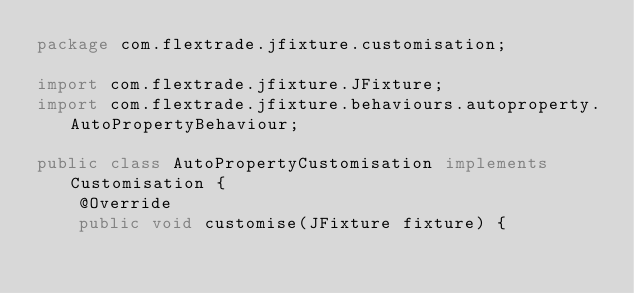<code> <loc_0><loc_0><loc_500><loc_500><_Java_>package com.flextrade.jfixture.customisation;

import com.flextrade.jfixture.JFixture;
import com.flextrade.jfixture.behaviours.autoproperty.AutoPropertyBehaviour;

public class AutoPropertyCustomisation implements Customisation {
    @Override
    public void customise(JFixture fixture) {
</code> 